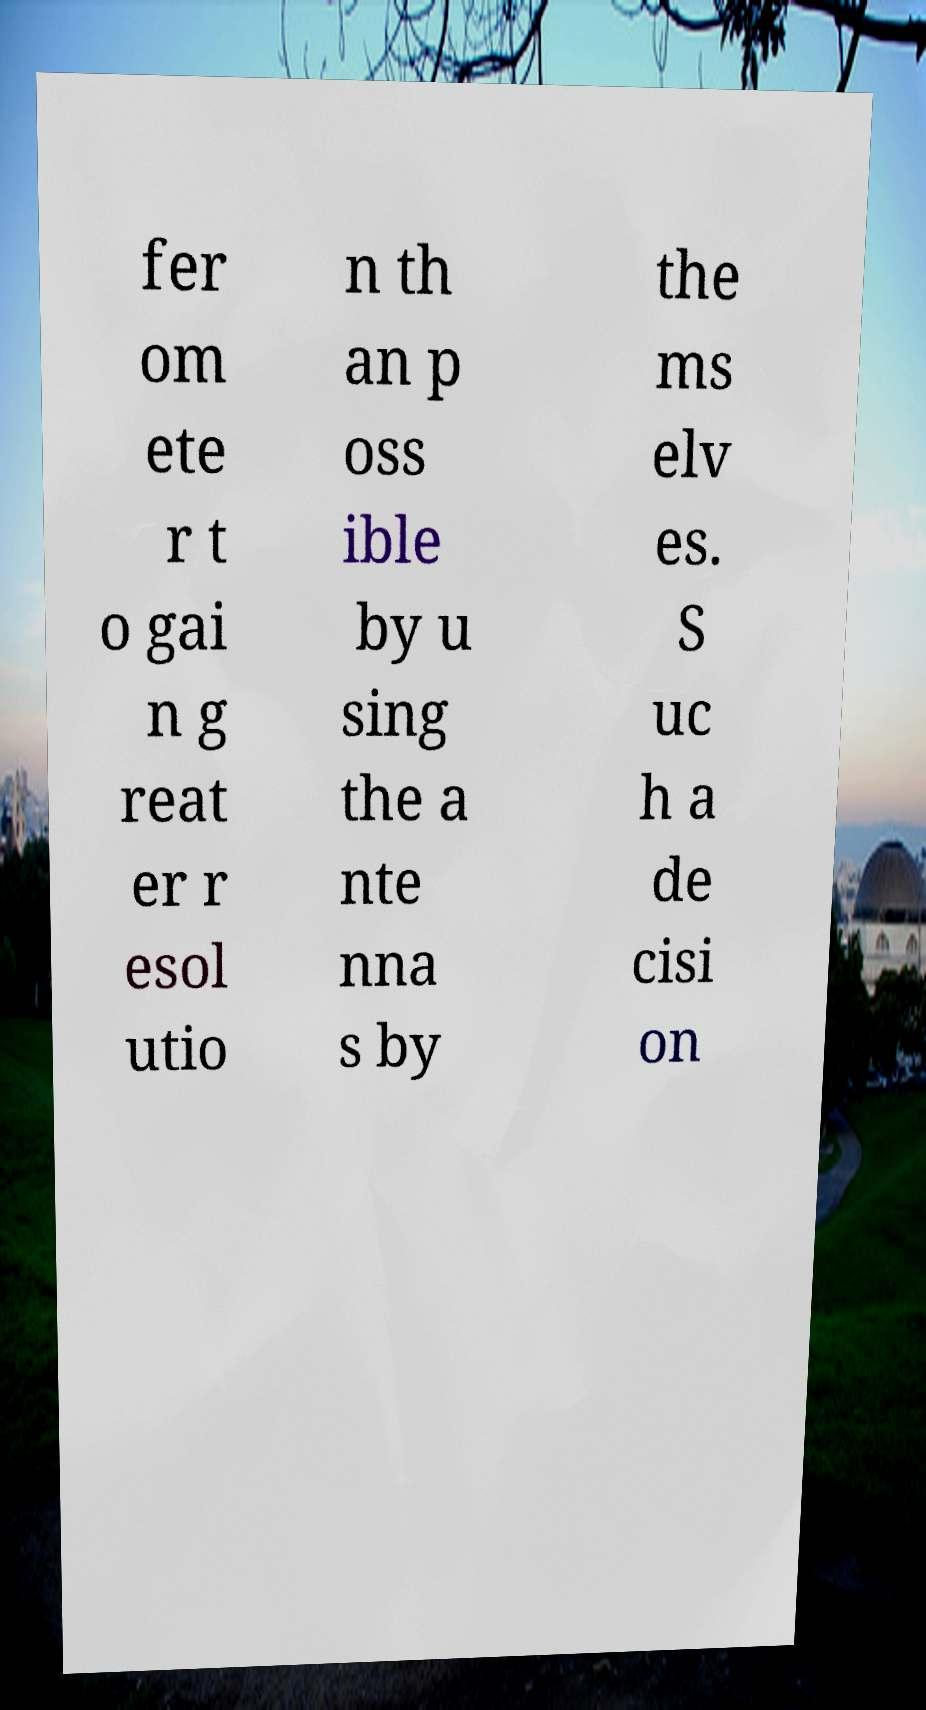Can you accurately transcribe the text from the provided image for me? fer om ete r t o gai n g reat er r esol utio n th an p oss ible by u sing the a nte nna s by the ms elv es. S uc h a de cisi on 